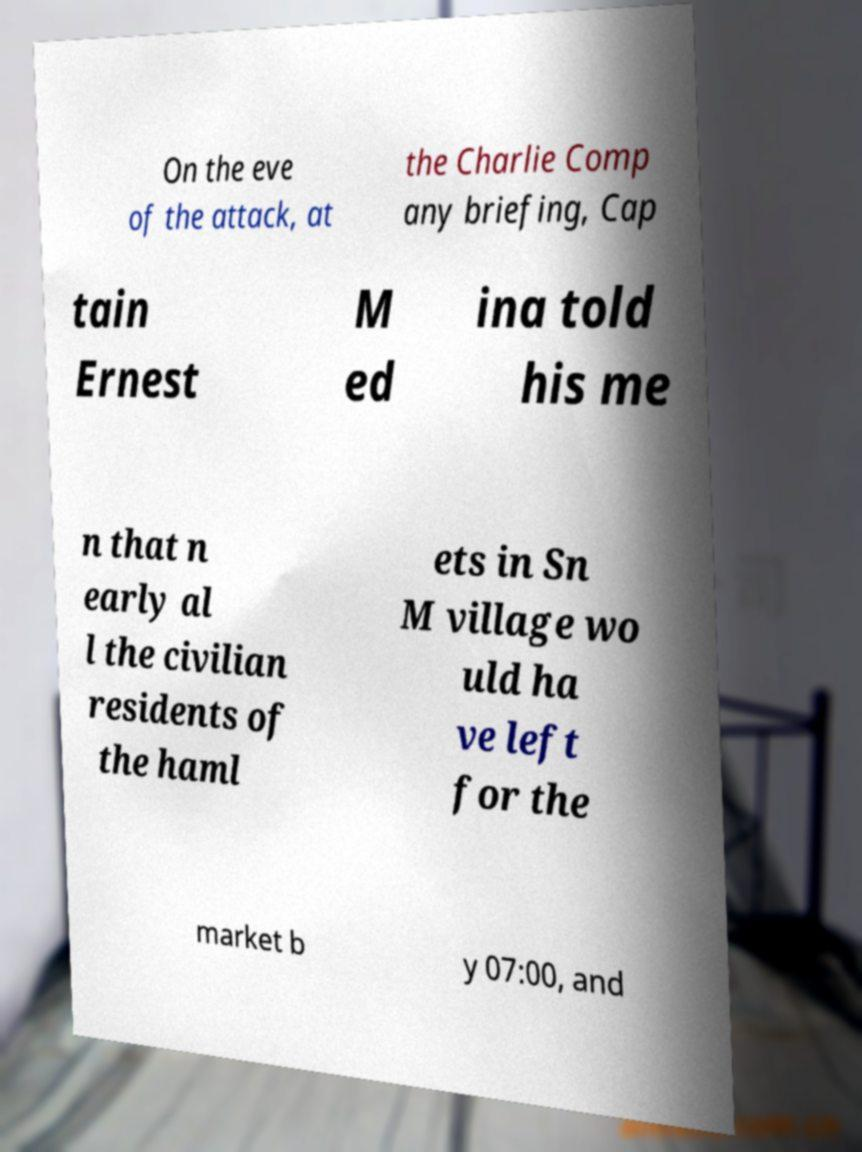For documentation purposes, I need the text within this image transcribed. Could you provide that? On the eve of the attack, at the Charlie Comp any briefing, Cap tain Ernest M ed ina told his me n that n early al l the civilian residents of the haml ets in Sn M village wo uld ha ve left for the market b y 07:00, and 